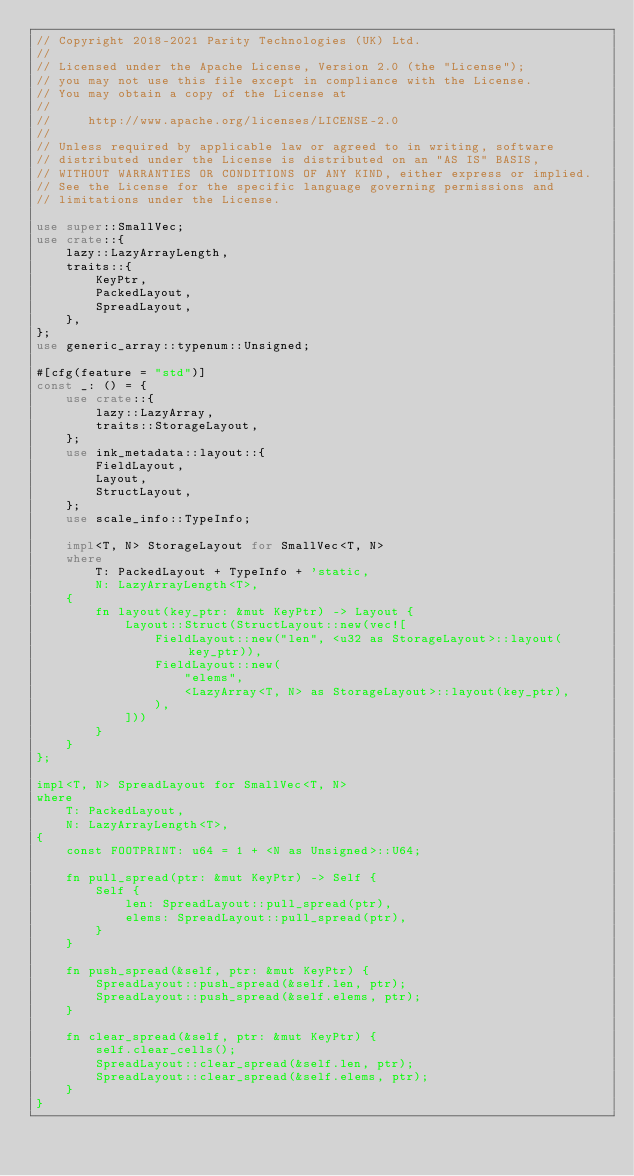Convert code to text. <code><loc_0><loc_0><loc_500><loc_500><_Rust_>// Copyright 2018-2021 Parity Technologies (UK) Ltd.
//
// Licensed under the Apache License, Version 2.0 (the "License");
// you may not use this file except in compliance with the License.
// You may obtain a copy of the License at
//
//     http://www.apache.org/licenses/LICENSE-2.0
//
// Unless required by applicable law or agreed to in writing, software
// distributed under the License is distributed on an "AS IS" BASIS,
// WITHOUT WARRANTIES OR CONDITIONS OF ANY KIND, either express or implied.
// See the License for the specific language governing permissions and
// limitations under the License.

use super::SmallVec;
use crate::{
    lazy::LazyArrayLength,
    traits::{
        KeyPtr,
        PackedLayout,
        SpreadLayout,
    },
};
use generic_array::typenum::Unsigned;

#[cfg(feature = "std")]
const _: () = {
    use crate::{
        lazy::LazyArray,
        traits::StorageLayout,
    };
    use ink_metadata::layout::{
        FieldLayout,
        Layout,
        StructLayout,
    };
    use scale_info::TypeInfo;

    impl<T, N> StorageLayout for SmallVec<T, N>
    where
        T: PackedLayout + TypeInfo + 'static,
        N: LazyArrayLength<T>,
    {
        fn layout(key_ptr: &mut KeyPtr) -> Layout {
            Layout::Struct(StructLayout::new(vec![
                FieldLayout::new("len", <u32 as StorageLayout>::layout(key_ptr)),
                FieldLayout::new(
                    "elems",
                    <LazyArray<T, N> as StorageLayout>::layout(key_ptr),
                ),
            ]))
        }
    }
};

impl<T, N> SpreadLayout for SmallVec<T, N>
where
    T: PackedLayout,
    N: LazyArrayLength<T>,
{
    const FOOTPRINT: u64 = 1 + <N as Unsigned>::U64;

    fn pull_spread(ptr: &mut KeyPtr) -> Self {
        Self {
            len: SpreadLayout::pull_spread(ptr),
            elems: SpreadLayout::pull_spread(ptr),
        }
    }

    fn push_spread(&self, ptr: &mut KeyPtr) {
        SpreadLayout::push_spread(&self.len, ptr);
        SpreadLayout::push_spread(&self.elems, ptr);
    }

    fn clear_spread(&self, ptr: &mut KeyPtr) {
        self.clear_cells();
        SpreadLayout::clear_spread(&self.len, ptr);
        SpreadLayout::clear_spread(&self.elems, ptr);
    }
}
</code> 